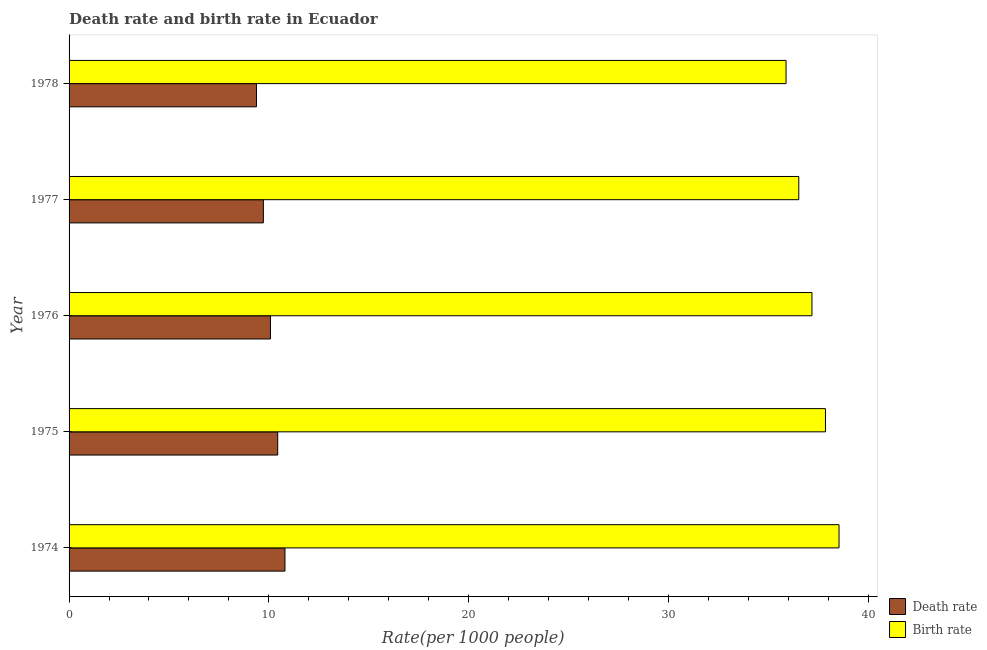How many different coloured bars are there?
Your response must be concise. 2. How many groups of bars are there?
Ensure brevity in your answer.  5. Are the number of bars per tick equal to the number of legend labels?
Offer a very short reply. Yes. Are the number of bars on each tick of the Y-axis equal?
Your answer should be very brief. Yes. How many bars are there on the 5th tick from the bottom?
Your answer should be compact. 2. What is the label of the 5th group of bars from the top?
Keep it short and to the point. 1974. In how many cases, is the number of bars for a given year not equal to the number of legend labels?
Offer a terse response. 0. What is the death rate in 1977?
Ensure brevity in your answer.  9.73. Across all years, what is the maximum birth rate?
Your response must be concise. 38.54. Across all years, what is the minimum birth rate?
Offer a terse response. 35.89. In which year was the death rate maximum?
Provide a short and direct response. 1974. In which year was the birth rate minimum?
Offer a very short reply. 1978. What is the total birth rate in the graph?
Your answer should be very brief. 186.02. What is the difference between the birth rate in 1975 and that in 1977?
Make the answer very short. 1.34. What is the difference between the birth rate in 1975 and the death rate in 1977?
Your answer should be very brief. 28.14. What is the average birth rate per year?
Give a very brief answer. 37.2. In the year 1975, what is the difference between the birth rate and death rate?
Offer a terse response. 27.42. What is the ratio of the death rate in 1974 to that in 1978?
Keep it short and to the point. 1.15. What is the difference between the highest and the second highest birth rate?
Ensure brevity in your answer.  0.68. What is the difference between the highest and the lowest birth rate?
Your answer should be compact. 2.65. What does the 2nd bar from the top in 1975 represents?
Offer a very short reply. Death rate. What does the 1st bar from the bottom in 1977 represents?
Give a very brief answer. Death rate. Are the values on the major ticks of X-axis written in scientific E-notation?
Your response must be concise. No. Where does the legend appear in the graph?
Provide a succinct answer. Bottom right. How many legend labels are there?
Offer a terse response. 2. How are the legend labels stacked?
Ensure brevity in your answer.  Vertical. What is the title of the graph?
Give a very brief answer. Death rate and birth rate in Ecuador. Does "GDP at market prices" appear as one of the legend labels in the graph?
Provide a succinct answer. No. What is the label or title of the X-axis?
Your answer should be very brief. Rate(per 1000 people). What is the label or title of the Y-axis?
Give a very brief answer. Year. What is the Rate(per 1000 people) of Death rate in 1974?
Keep it short and to the point. 10.81. What is the Rate(per 1000 people) of Birth rate in 1974?
Make the answer very short. 38.54. What is the Rate(per 1000 people) of Death rate in 1975?
Ensure brevity in your answer.  10.44. What is the Rate(per 1000 people) of Birth rate in 1975?
Your answer should be compact. 37.87. What is the Rate(per 1000 people) in Death rate in 1976?
Provide a short and direct response. 10.08. What is the Rate(per 1000 people) of Birth rate in 1976?
Offer a terse response. 37.19. What is the Rate(per 1000 people) of Death rate in 1977?
Provide a short and direct response. 9.73. What is the Rate(per 1000 people) in Birth rate in 1977?
Make the answer very short. 36.53. What is the Rate(per 1000 people) in Death rate in 1978?
Make the answer very short. 9.38. What is the Rate(per 1000 people) in Birth rate in 1978?
Your answer should be very brief. 35.89. Across all years, what is the maximum Rate(per 1000 people) of Death rate?
Make the answer very short. 10.81. Across all years, what is the maximum Rate(per 1000 people) of Birth rate?
Provide a succinct answer. 38.54. Across all years, what is the minimum Rate(per 1000 people) in Death rate?
Provide a succinct answer. 9.38. Across all years, what is the minimum Rate(per 1000 people) in Birth rate?
Your answer should be compact. 35.89. What is the total Rate(per 1000 people) of Death rate in the graph?
Your answer should be very brief. 50.44. What is the total Rate(per 1000 people) in Birth rate in the graph?
Offer a very short reply. 186.02. What is the difference between the Rate(per 1000 people) in Death rate in 1974 and that in 1975?
Your answer should be very brief. 0.36. What is the difference between the Rate(per 1000 people) of Birth rate in 1974 and that in 1975?
Keep it short and to the point. 0.68. What is the difference between the Rate(per 1000 people) of Death rate in 1974 and that in 1976?
Give a very brief answer. 0.73. What is the difference between the Rate(per 1000 people) in Birth rate in 1974 and that in 1976?
Give a very brief answer. 1.35. What is the difference between the Rate(per 1000 people) of Death rate in 1974 and that in 1977?
Your answer should be very brief. 1.08. What is the difference between the Rate(per 1000 people) in Birth rate in 1974 and that in 1977?
Your answer should be compact. 2.02. What is the difference between the Rate(per 1000 people) in Death rate in 1974 and that in 1978?
Keep it short and to the point. 1.43. What is the difference between the Rate(per 1000 people) of Birth rate in 1974 and that in 1978?
Make the answer very short. 2.65. What is the difference between the Rate(per 1000 people) of Death rate in 1975 and that in 1976?
Offer a terse response. 0.36. What is the difference between the Rate(per 1000 people) of Birth rate in 1975 and that in 1976?
Provide a short and direct response. 0.68. What is the difference between the Rate(per 1000 people) of Death rate in 1975 and that in 1977?
Offer a very short reply. 0.72. What is the difference between the Rate(per 1000 people) of Birth rate in 1975 and that in 1977?
Ensure brevity in your answer.  1.34. What is the difference between the Rate(per 1000 people) in Death rate in 1975 and that in 1978?
Your response must be concise. 1.06. What is the difference between the Rate(per 1000 people) of Birth rate in 1975 and that in 1978?
Make the answer very short. 1.97. What is the difference between the Rate(per 1000 people) of Death rate in 1976 and that in 1977?
Your answer should be compact. 0.35. What is the difference between the Rate(per 1000 people) in Birth rate in 1976 and that in 1977?
Your answer should be compact. 0.66. What is the difference between the Rate(per 1000 people) of Death rate in 1976 and that in 1978?
Provide a succinct answer. 0.7. What is the difference between the Rate(per 1000 people) in Birth rate in 1976 and that in 1978?
Give a very brief answer. 1.3. What is the difference between the Rate(per 1000 people) in Death rate in 1977 and that in 1978?
Provide a short and direct response. 0.34. What is the difference between the Rate(per 1000 people) in Birth rate in 1977 and that in 1978?
Keep it short and to the point. 0.64. What is the difference between the Rate(per 1000 people) in Death rate in 1974 and the Rate(per 1000 people) in Birth rate in 1975?
Ensure brevity in your answer.  -27.06. What is the difference between the Rate(per 1000 people) of Death rate in 1974 and the Rate(per 1000 people) of Birth rate in 1976?
Offer a terse response. -26.38. What is the difference between the Rate(per 1000 people) of Death rate in 1974 and the Rate(per 1000 people) of Birth rate in 1977?
Offer a very short reply. -25.72. What is the difference between the Rate(per 1000 people) of Death rate in 1974 and the Rate(per 1000 people) of Birth rate in 1978?
Ensure brevity in your answer.  -25.08. What is the difference between the Rate(per 1000 people) in Death rate in 1975 and the Rate(per 1000 people) in Birth rate in 1976?
Keep it short and to the point. -26.75. What is the difference between the Rate(per 1000 people) in Death rate in 1975 and the Rate(per 1000 people) in Birth rate in 1977?
Give a very brief answer. -26.09. What is the difference between the Rate(per 1000 people) in Death rate in 1975 and the Rate(per 1000 people) in Birth rate in 1978?
Your answer should be compact. -25.45. What is the difference between the Rate(per 1000 people) in Death rate in 1976 and the Rate(per 1000 people) in Birth rate in 1977?
Ensure brevity in your answer.  -26.45. What is the difference between the Rate(per 1000 people) in Death rate in 1976 and the Rate(per 1000 people) in Birth rate in 1978?
Provide a succinct answer. -25.81. What is the difference between the Rate(per 1000 people) of Death rate in 1977 and the Rate(per 1000 people) of Birth rate in 1978?
Ensure brevity in your answer.  -26.17. What is the average Rate(per 1000 people) of Death rate per year?
Your answer should be very brief. 10.09. What is the average Rate(per 1000 people) in Birth rate per year?
Give a very brief answer. 37.2. In the year 1974, what is the difference between the Rate(per 1000 people) in Death rate and Rate(per 1000 people) in Birth rate?
Provide a short and direct response. -27.74. In the year 1975, what is the difference between the Rate(per 1000 people) in Death rate and Rate(per 1000 people) in Birth rate?
Keep it short and to the point. -27.42. In the year 1976, what is the difference between the Rate(per 1000 people) in Death rate and Rate(per 1000 people) in Birth rate?
Your answer should be very brief. -27.11. In the year 1977, what is the difference between the Rate(per 1000 people) of Death rate and Rate(per 1000 people) of Birth rate?
Keep it short and to the point. -26.8. In the year 1978, what is the difference between the Rate(per 1000 people) of Death rate and Rate(per 1000 people) of Birth rate?
Your answer should be very brief. -26.51. What is the ratio of the Rate(per 1000 people) of Death rate in 1974 to that in 1975?
Your answer should be very brief. 1.03. What is the ratio of the Rate(per 1000 people) in Birth rate in 1974 to that in 1975?
Keep it short and to the point. 1.02. What is the ratio of the Rate(per 1000 people) of Death rate in 1974 to that in 1976?
Your answer should be very brief. 1.07. What is the ratio of the Rate(per 1000 people) in Birth rate in 1974 to that in 1976?
Provide a short and direct response. 1.04. What is the ratio of the Rate(per 1000 people) of Death rate in 1974 to that in 1977?
Make the answer very short. 1.11. What is the ratio of the Rate(per 1000 people) of Birth rate in 1974 to that in 1977?
Make the answer very short. 1.06. What is the ratio of the Rate(per 1000 people) in Death rate in 1974 to that in 1978?
Offer a very short reply. 1.15. What is the ratio of the Rate(per 1000 people) of Birth rate in 1974 to that in 1978?
Ensure brevity in your answer.  1.07. What is the ratio of the Rate(per 1000 people) of Death rate in 1975 to that in 1976?
Your response must be concise. 1.04. What is the ratio of the Rate(per 1000 people) in Birth rate in 1975 to that in 1976?
Keep it short and to the point. 1.02. What is the ratio of the Rate(per 1000 people) of Death rate in 1975 to that in 1977?
Your answer should be compact. 1.07. What is the ratio of the Rate(per 1000 people) of Birth rate in 1975 to that in 1977?
Offer a very short reply. 1.04. What is the ratio of the Rate(per 1000 people) of Death rate in 1975 to that in 1978?
Your answer should be compact. 1.11. What is the ratio of the Rate(per 1000 people) of Birth rate in 1975 to that in 1978?
Your answer should be very brief. 1.05. What is the ratio of the Rate(per 1000 people) of Death rate in 1976 to that in 1977?
Your answer should be compact. 1.04. What is the ratio of the Rate(per 1000 people) in Birth rate in 1976 to that in 1977?
Provide a short and direct response. 1.02. What is the ratio of the Rate(per 1000 people) in Death rate in 1976 to that in 1978?
Give a very brief answer. 1.07. What is the ratio of the Rate(per 1000 people) in Birth rate in 1976 to that in 1978?
Give a very brief answer. 1.04. What is the ratio of the Rate(per 1000 people) of Death rate in 1977 to that in 1978?
Provide a succinct answer. 1.04. What is the ratio of the Rate(per 1000 people) of Birth rate in 1977 to that in 1978?
Provide a short and direct response. 1.02. What is the difference between the highest and the second highest Rate(per 1000 people) in Death rate?
Offer a terse response. 0.36. What is the difference between the highest and the second highest Rate(per 1000 people) in Birth rate?
Give a very brief answer. 0.68. What is the difference between the highest and the lowest Rate(per 1000 people) of Death rate?
Keep it short and to the point. 1.43. What is the difference between the highest and the lowest Rate(per 1000 people) of Birth rate?
Ensure brevity in your answer.  2.65. 